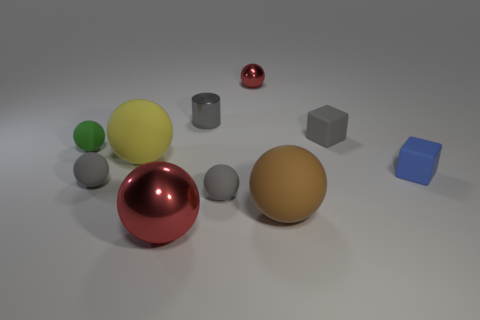Subtract all gray rubber spheres. How many spheres are left? 5 Subtract all cylinders. How many objects are left? 9 Subtract 1 balls. How many balls are left? 6 Subtract all cyan balls. Subtract all purple cylinders. How many balls are left? 7 Subtract all red balls. How many blue cubes are left? 1 Subtract all tiny red shiny balls. Subtract all gray objects. How many objects are left? 5 Add 8 tiny cylinders. How many tiny cylinders are left? 9 Add 5 matte spheres. How many matte spheres exist? 10 Subtract all brown spheres. How many spheres are left? 6 Subtract 0 brown cubes. How many objects are left? 10 